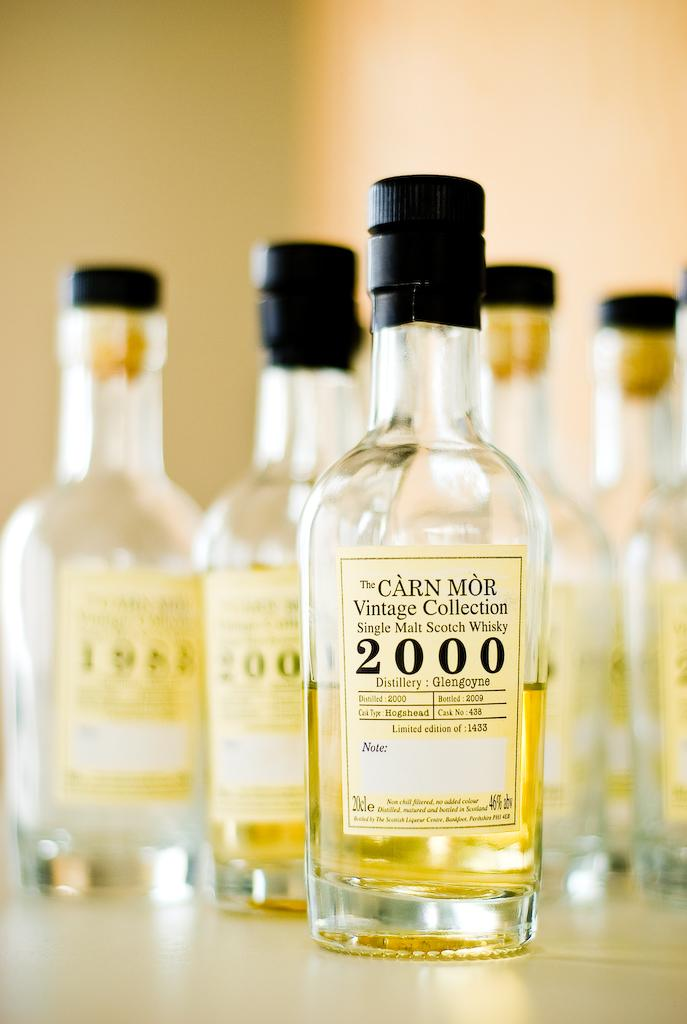<image>
Provide a brief description of the given image. A cluster of bottles from the Carn Mor Vintage Collection of Single Malt Scotch Whisky. 